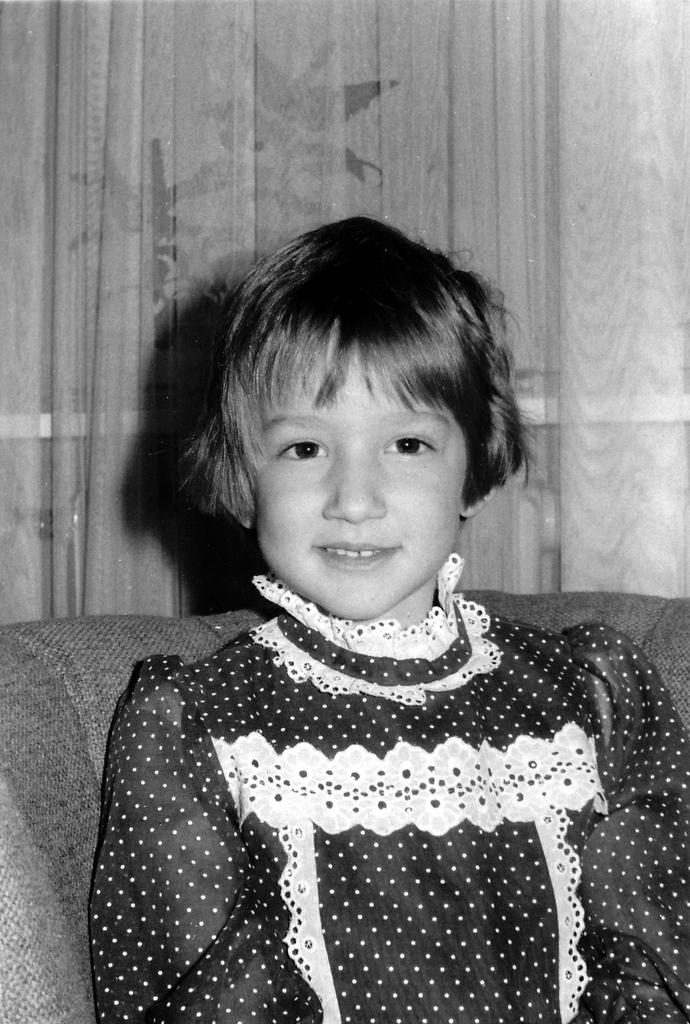What is the color scheme of the image? The image is black and white. What can be seen in the image besides the color scheme? There is a person sitting on a sofa in the image. What is visible in the background of the image? There is a curtain in the background of the image. How many girls are walking on the road in the image? There are no girls or roads present in the image. What type of engine is visible in the image? There is no engine present in the image. 